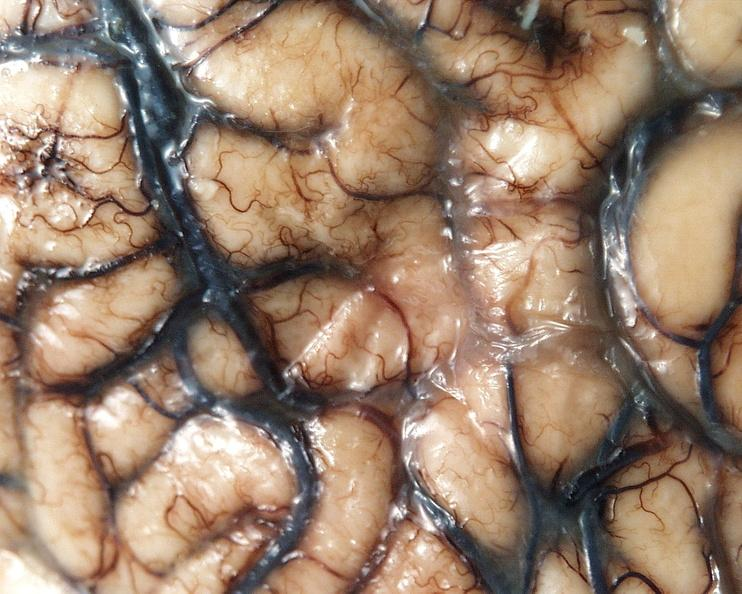what is present?
Answer the question using a single word or phrase. Nervous 